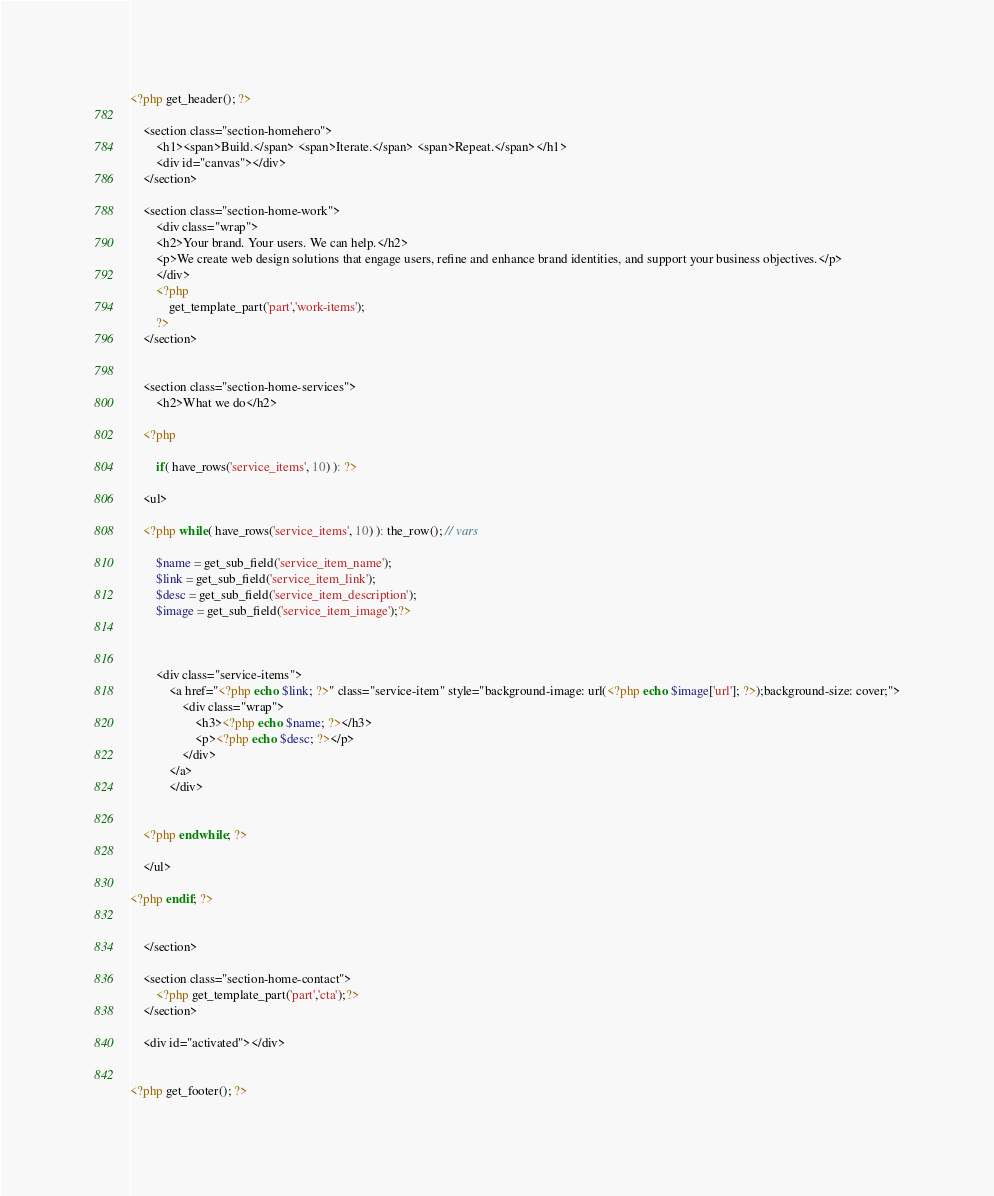Convert code to text. <code><loc_0><loc_0><loc_500><loc_500><_PHP_><?php get_header(); ?>

	<section class="section-homehero">
		<h1><span>Build.</span> <span>Iterate.</span> <span>Repeat.</span></h1>
		<div id="canvas"></div>
	</section>
	
	<section class="section-home-work">
		<div class="wrap">
		<h2>Your brand. Your users. We can help.</h2>
		<p>We create web design solutions that engage users, refine and enhance brand identities, and support your business objectives.</p>
		</div>
		<?php
			get_template_part('part','work-items');
		?>
	</section>

	
	<section class="section-home-services">
		<h2>What we do</h2>
		
	<?php 

		if( have_rows('service_items', 10) ): ?>

    <ul>

    <?php while( have_rows('service_items', 10) ): the_row(); // vars
		
		$name = get_sub_field('service_item_name');
		$link = get_sub_field('service_item_link');
		$desc = get_sub_field('service_item_description');
		$image = get_sub_field('service_item_image');?>
    
		
	
		<div class="service-items">
			<a href="<?php echo $link; ?>" class="service-item" style="background-image: url(<?php echo $image['url']; ?>);background-size: cover;">
				<div class="wrap">
					<h3><?php echo $name; ?></h3>
					<p><?php echo $desc; ?></p>
				</div>
			</a>
    		</div>
	
	
    <?php endwhile; ?>

    </ul>

<?php endif; ?>


	</section>
	
	<section class="section-home-contact">
		<?php get_template_part('part','cta');?>		
	</section>

	<div id="activated"></div>


<?php get_footer(); ?></code> 